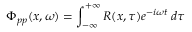<formula> <loc_0><loc_0><loc_500><loc_500>\Phi _ { p p } ( x , \omega ) = \int _ { - \infty } ^ { + \infty } R ( x , \tau ) e ^ { - i \omega t } \, d \tau</formula> 